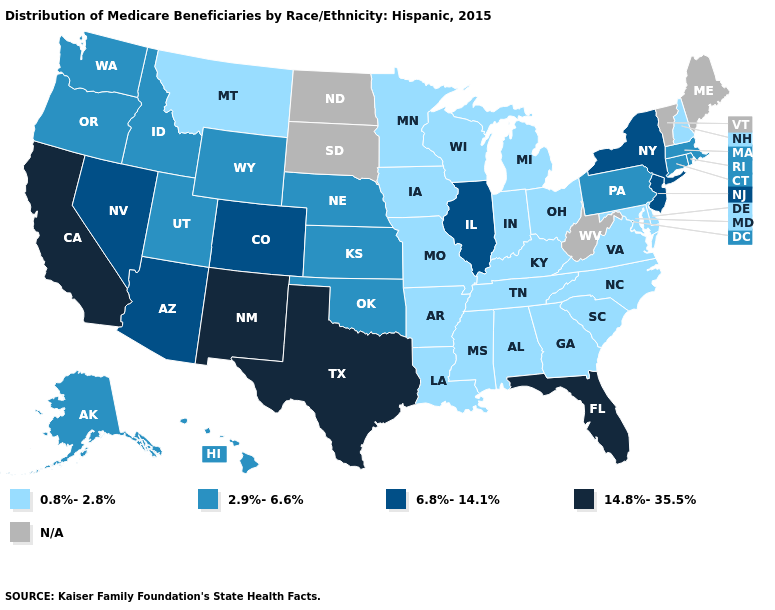What is the value of New York?
Keep it brief. 6.8%-14.1%. Does the first symbol in the legend represent the smallest category?
Concise answer only. Yes. Among the states that border Nebraska , which have the highest value?
Give a very brief answer. Colorado. Which states hav the highest value in the South?
Concise answer only. Florida, Texas. What is the highest value in states that border Arkansas?
Write a very short answer. 14.8%-35.5%. How many symbols are there in the legend?
Write a very short answer. 5. Name the states that have a value in the range 0.8%-2.8%?
Write a very short answer. Alabama, Arkansas, Delaware, Georgia, Indiana, Iowa, Kentucky, Louisiana, Maryland, Michigan, Minnesota, Mississippi, Missouri, Montana, New Hampshire, North Carolina, Ohio, South Carolina, Tennessee, Virginia, Wisconsin. Does Colorado have the lowest value in the USA?
Keep it brief. No. What is the highest value in the USA?
Be succinct. 14.8%-35.5%. Does New Mexico have the highest value in the West?
Write a very short answer. Yes. How many symbols are there in the legend?
Short answer required. 5. What is the highest value in the USA?
Give a very brief answer. 14.8%-35.5%. What is the value of Arizona?
Answer briefly. 6.8%-14.1%. What is the highest value in states that border Texas?
Quick response, please. 14.8%-35.5%. 